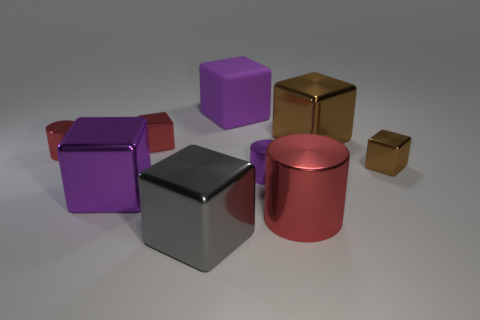What can these objects tell us about the surface they're resting on? The surface upon which the objects rest is smooth and nondescript, likely chosen to minimize distraction from the objects themselves. The uniform shadows and lack of visible texture or pattern suggest it's a synthetic or virtual backdrop, often used in 3D modeling or product photography to emphasize the items on display. 